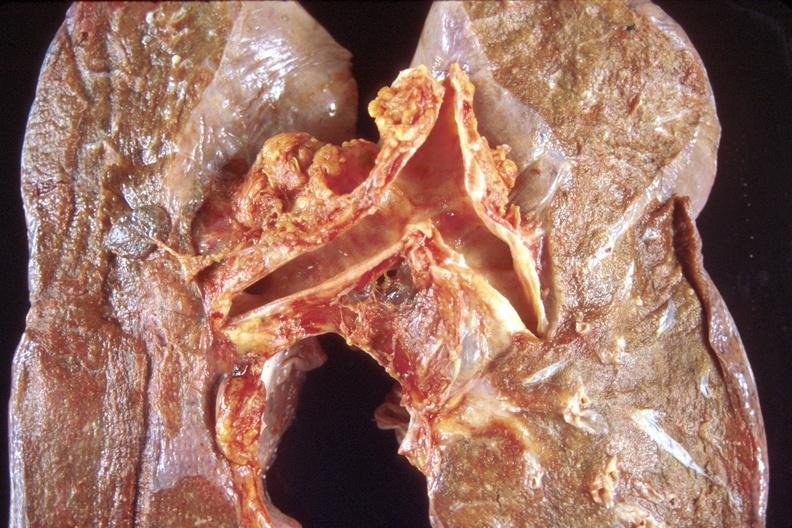what is present?
Answer the question using a single word or phrase. Respiratory 